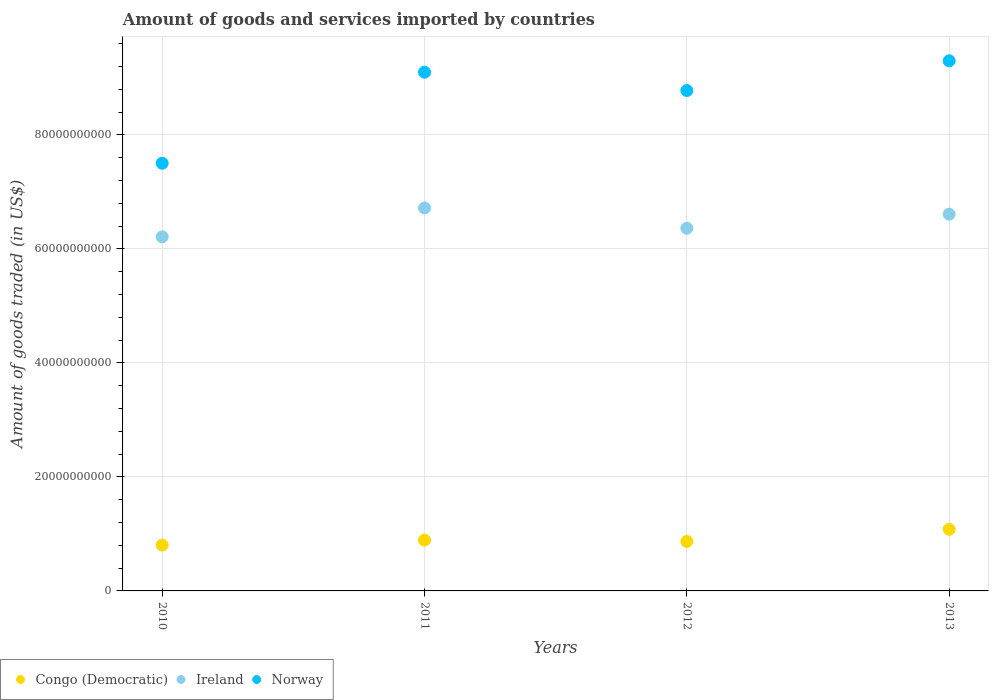How many different coloured dotlines are there?
Keep it short and to the point. 3. Is the number of dotlines equal to the number of legend labels?
Your answer should be compact. Yes. What is the total amount of goods and services imported in Ireland in 2013?
Give a very brief answer. 6.61e+1. Across all years, what is the maximum total amount of goods and services imported in Congo (Democratic)?
Provide a succinct answer. 1.08e+1. Across all years, what is the minimum total amount of goods and services imported in Congo (Democratic)?
Make the answer very short. 8.04e+09. In which year was the total amount of goods and services imported in Congo (Democratic) maximum?
Ensure brevity in your answer.  2013. In which year was the total amount of goods and services imported in Congo (Democratic) minimum?
Provide a short and direct response. 2010. What is the total total amount of goods and services imported in Ireland in the graph?
Your answer should be very brief. 2.59e+11. What is the difference between the total amount of goods and services imported in Ireland in 2011 and that in 2013?
Provide a short and direct response. 1.09e+09. What is the difference between the total amount of goods and services imported in Congo (Democratic) in 2011 and the total amount of goods and services imported in Ireland in 2012?
Your answer should be very brief. -5.47e+1. What is the average total amount of goods and services imported in Congo (Democratic) per year?
Keep it short and to the point. 9.11e+09. In the year 2012, what is the difference between the total amount of goods and services imported in Congo (Democratic) and total amount of goods and services imported in Ireland?
Keep it short and to the point. -5.50e+1. What is the ratio of the total amount of goods and services imported in Norway in 2011 to that in 2012?
Ensure brevity in your answer.  1.04. Is the total amount of goods and services imported in Norway in 2011 less than that in 2012?
Provide a short and direct response. No. Is the difference between the total amount of goods and services imported in Congo (Democratic) in 2011 and 2013 greater than the difference between the total amount of goods and services imported in Ireland in 2011 and 2013?
Make the answer very short. No. What is the difference between the highest and the second highest total amount of goods and services imported in Ireland?
Keep it short and to the point. 1.09e+09. What is the difference between the highest and the lowest total amount of goods and services imported in Ireland?
Ensure brevity in your answer.  5.07e+09. Is it the case that in every year, the sum of the total amount of goods and services imported in Ireland and total amount of goods and services imported in Norway  is greater than the total amount of goods and services imported in Congo (Democratic)?
Make the answer very short. Yes. Is the total amount of goods and services imported in Norway strictly less than the total amount of goods and services imported in Congo (Democratic) over the years?
Provide a succinct answer. No. Does the graph contain grids?
Ensure brevity in your answer.  Yes. What is the title of the graph?
Offer a terse response. Amount of goods and services imported by countries. What is the label or title of the Y-axis?
Keep it short and to the point. Amount of goods traded (in US$). What is the Amount of goods traded (in US$) of Congo (Democratic) in 2010?
Make the answer very short. 8.04e+09. What is the Amount of goods traded (in US$) in Ireland in 2010?
Your response must be concise. 6.21e+1. What is the Amount of goods traded (in US$) in Norway in 2010?
Give a very brief answer. 7.50e+1. What is the Amount of goods traded (in US$) in Congo (Democratic) in 2011?
Provide a succinct answer. 8.92e+09. What is the Amount of goods traded (in US$) of Ireland in 2011?
Offer a terse response. 6.72e+1. What is the Amount of goods traded (in US$) in Norway in 2011?
Ensure brevity in your answer.  9.10e+1. What is the Amount of goods traded (in US$) of Congo (Democratic) in 2012?
Offer a terse response. 8.68e+09. What is the Amount of goods traded (in US$) in Ireland in 2012?
Give a very brief answer. 6.36e+1. What is the Amount of goods traded (in US$) in Norway in 2012?
Keep it short and to the point. 8.78e+1. What is the Amount of goods traded (in US$) in Congo (Democratic) in 2013?
Make the answer very short. 1.08e+1. What is the Amount of goods traded (in US$) in Ireland in 2013?
Keep it short and to the point. 6.61e+1. What is the Amount of goods traded (in US$) in Norway in 2013?
Offer a very short reply. 9.30e+1. Across all years, what is the maximum Amount of goods traded (in US$) of Congo (Democratic)?
Provide a succinct answer. 1.08e+1. Across all years, what is the maximum Amount of goods traded (in US$) in Ireland?
Your answer should be compact. 6.72e+1. Across all years, what is the maximum Amount of goods traded (in US$) of Norway?
Your response must be concise. 9.30e+1. Across all years, what is the minimum Amount of goods traded (in US$) of Congo (Democratic)?
Ensure brevity in your answer.  8.04e+09. Across all years, what is the minimum Amount of goods traded (in US$) of Ireland?
Keep it short and to the point. 6.21e+1. Across all years, what is the minimum Amount of goods traded (in US$) in Norway?
Give a very brief answer. 7.50e+1. What is the total Amount of goods traded (in US$) in Congo (Democratic) in the graph?
Keep it short and to the point. 3.64e+1. What is the total Amount of goods traded (in US$) of Ireland in the graph?
Ensure brevity in your answer.  2.59e+11. What is the total Amount of goods traded (in US$) in Norway in the graph?
Offer a very short reply. 3.47e+11. What is the difference between the Amount of goods traded (in US$) in Congo (Democratic) in 2010 and that in 2011?
Your answer should be very brief. -8.73e+08. What is the difference between the Amount of goods traded (in US$) in Ireland in 2010 and that in 2011?
Provide a short and direct response. -5.07e+09. What is the difference between the Amount of goods traded (in US$) in Norway in 2010 and that in 2011?
Offer a very short reply. -1.60e+1. What is the difference between the Amount of goods traded (in US$) in Congo (Democratic) in 2010 and that in 2012?
Provide a short and direct response. -6.35e+08. What is the difference between the Amount of goods traded (in US$) of Ireland in 2010 and that in 2012?
Give a very brief answer. -1.50e+09. What is the difference between the Amount of goods traded (in US$) of Norway in 2010 and that in 2012?
Provide a succinct answer. -1.28e+1. What is the difference between the Amount of goods traded (in US$) of Congo (Democratic) in 2010 and that in 2013?
Give a very brief answer. -2.77e+09. What is the difference between the Amount of goods traded (in US$) of Ireland in 2010 and that in 2013?
Give a very brief answer. -3.98e+09. What is the difference between the Amount of goods traded (in US$) of Norway in 2010 and that in 2013?
Provide a short and direct response. -1.80e+1. What is the difference between the Amount of goods traded (in US$) in Congo (Democratic) in 2011 and that in 2012?
Provide a succinct answer. 2.38e+08. What is the difference between the Amount of goods traded (in US$) in Ireland in 2011 and that in 2012?
Ensure brevity in your answer.  3.57e+09. What is the difference between the Amount of goods traded (in US$) of Norway in 2011 and that in 2012?
Your answer should be very brief. 3.21e+09. What is the difference between the Amount of goods traded (in US$) of Congo (Democratic) in 2011 and that in 2013?
Provide a short and direct response. -1.89e+09. What is the difference between the Amount of goods traded (in US$) of Ireland in 2011 and that in 2013?
Your answer should be very brief. 1.09e+09. What is the difference between the Amount of goods traded (in US$) in Norway in 2011 and that in 2013?
Provide a short and direct response. -2.00e+09. What is the difference between the Amount of goods traded (in US$) of Congo (Democratic) in 2012 and that in 2013?
Your response must be concise. -2.13e+09. What is the difference between the Amount of goods traded (in US$) in Ireland in 2012 and that in 2013?
Give a very brief answer. -2.47e+09. What is the difference between the Amount of goods traded (in US$) in Norway in 2012 and that in 2013?
Your response must be concise. -5.22e+09. What is the difference between the Amount of goods traded (in US$) in Congo (Democratic) in 2010 and the Amount of goods traded (in US$) in Ireland in 2011?
Make the answer very short. -5.92e+1. What is the difference between the Amount of goods traded (in US$) in Congo (Democratic) in 2010 and the Amount of goods traded (in US$) in Norway in 2011?
Your response must be concise. -8.30e+1. What is the difference between the Amount of goods traded (in US$) in Ireland in 2010 and the Amount of goods traded (in US$) in Norway in 2011?
Offer a terse response. -2.89e+1. What is the difference between the Amount of goods traded (in US$) in Congo (Democratic) in 2010 and the Amount of goods traded (in US$) in Ireland in 2012?
Provide a succinct answer. -5.56e+1. What is the difference between the Amount of goods traded (in US$) of Congo (Democratic) in 2010 and the Amount of goods traded (in US$) of Norway in 2012?
Your response must be concise. -7.98e+1. What is the difference between the Amount of goods traded (in US$) in Ireland in 2010 and the Amount of goods traded (in US$) in Norway in 2012?
Provide a succinct answer. -2.57e+1. What is the difference between the Amount of goods traded (in US$) of Congo (Democratic) in 2010 and the Amount of goods traded (in US$) of Ireland in 2013?
Make the answer very short. -5.81e+1. What is the difference between the Amount of goods traded (in US$) of Congo (Democratic) in 2010 and the Amount of goods traded (in US$) of Norway in 2013?
Offer a terse response. -8.50e+1. What is the difference between the Amount of goods traded (in US$) of Ireland in 2010 and the Amount of goods traded (in US$) of Norway in 2013?
Make the answer very short. -3.09e+1. What is the difference between the Amount of goods traded (in US$) in Congo (Democratic) in 2011 and the Amount of goods traded (in US$) in Ireland in 2012?
Your answer should be very brief. -5.47e+1. What is the difference between the Amount of goods traded (in US$) of Congo (Democratic) in 2011 and the Amount of goods traded (in US$) of Norway in 2012?
Your answer should be very brief. -7.89e+1. What is the difference between the Amount of goods traded (in US$) of Ireland in 2011 and the Amount of goods traded (in US$) of Norway in 2012?
Keep it short and to the point. -2.06e+1. What is the difference between the Amount of goods traded (in US$) in Congo (Democratic) in 2011 and the Amount of goods traded (in US$) in Ireland in 2013?
Your response must be concise. -5.72e+1. What is the difference between the Amount of goods traded (in US$) of Congo (Democratic) in 2011 and the Amount of goods traded (in US$) of Norway in 2013?
Your answer should be compact. -8.41e+1. What is the difference between the Amount of goods traded (in US$) in Ireland in 2011 and the Amount of goods traded (in US$) in Norway in 2013?
Give a very brief answer. -2.58e+1. What is the difference between the Amount of goods traded (in US$) in Congo (Democratic) in 2012 and the Amount of goods traded (in US$) in Ireland in 2013?
Keep it short and to the point. -5.74e+1. What is the difference between the Amount of goods traded (in US$) of Congo (Democratic) in 2012 and the Amount of goods traded (in US$) of Norway in 2013?
Your answer should be compact. -8.43e+1. What is the difference between the Amount of goods traded (in US$) of Ireland in 2012 and the Amount of goods traded (in US$) of Norway in 2013?
Provide a short and direct response. -2.94e+1. What is the average Amount of goods traded (in US$) in Congo (Democratic) per year?
Offer a very short reply. 9.11e+09. What is the average Amount of goods traded (in US$) of Ireland per year?
Your answer should be very brief. 6.48e+1. What is the average Amount of goods traded (in US$) of Norway per year?
Give a very brief answer. 8.67e+1. In the year 2010, what is the difference between the Amount of goods traded (in US$) of Congo (Democratic) and Amount of goods traded (in US$) of Ireland?
Keep it short and to the point. -5.41e+1. In the year 2010, what is the difference between the Amount of goods traded (in US$) of Congo (Democratic) and Amount of goods traded (in US$) of Norway?
Provide a short and direct response. -6.70e+1. In the year 2010, what is the difference between the Amount of goods traded (in US$) in Ireland and Amount of goods traded (in US$) in Norway?
Give a very brief answer. -1.29e+1. In the year 2011, what is the difference between the Amount of goods traded (in US$) of Congo (Democratic) and Amount of goods traded (in US$) of Ireland?
Provide a short and direct response. -5.83e+1. In the year 2011, what is the difference between the Amount of goods traded (in US$) in Congo (Democratic) and Amount of goods traded (in US$) in Norway?
Your answer should be very brief. -8.21e+1. In the year 2011, what is the difference between the Amount of goods traded (in US$) of Ireland and Amount of goods traded (in US$) of Norway?
Your response must be concise. -2.38e+1. In the year 2012, what is the difference between the Amount of goods traded (in US$) in Congo (Democratic) and Amount of goods traded (in US$) in Ireland?
Give a very brief answer. -5.50e+1. In the year 2012, what is the difference between the Amount of goods traded (in US$) in Congo (Democratic) and Amount of goods traded (in US$) in Norway?
Give a very brief answer. -7.91e+1. In the year 2012, what is the difference between the Amount of goods traded (in US$) of Ireland and Amount of goods traded (in US$) of Norway?
Give a very brief answer. -2.42e+1. In the year 2013, what is the difference between the Amount of goods traded (in US$) of Congo (Democratic) and Amount of goods traded (in US$) of Ireland?
Offer a terse response. -5.53e+1. In the year 2013, what is the difference between the Amount of goods traded (in US$) of Congo (Democratic) and Amount of goods traded (in US$) of Norway?
Make the answer very short. -8.22e+1. In the year 2013, what is the difference between the Amount of goods traded (in US$) of Ireland and Amount of goods traded (in US$) of Norway?
Offer a very short reply. -2.69e+1. What is the ratio of the Amount of goods traded (in US$) in Congo (Democratic) in 2010 to that in 2011?
Your answer should be very brief. 0.9. What is the ratio of the Amount of goods traded (in US$) of Ireland in 2010 to that in 2011?
Provide a succinct answer. 0.92. What is the ratio of the Amount of goods traded (in US$) of Norway in 2010 to that in 2011?
Provide a short and direct response. 0.82. What is the ratio of the Amount of goods traded (in US$) in Congo (Democratic) in 2010 to that in 2012?
Your answer should be compact. 0.93. What is the ratio of the Amount of goods traded (in US$) in Ireland in 2010 to that in 2012?
Your answer should be compact. 0.98. What is the ratio of the Amount of goods traded (in US$) of Norway in 2010 to that in 2012?
Give a very brief answer. 0.85. What is the ratio of the Amount of goods traded (in US$) of Congo (Democratic) in 2010 to that in 2013?
Your response must be concise. 0.74. What is the ratio of the Amount of goods traded (in US$) of Ireland in 2010 to that in 2013?
Keep it short and to the point. 0.94. What is the ratio of the Amount of goods traded (in US$) in Norway in 2010 to that in 2013?
Provide a succinct answer. 0.81. What is the ratio of the Amount of goods traded (in US$) of Congo (Democratic) in 2011 to that in 2012?
Give a very brief answer. 1.03. What is the ratio of the Amount of goods traded (in US$) in Ireland in 2011 to that in 2012?
Your answer should be compact. 1.06. What is the ratio of the Amount of goods traded (in US$) in Norway in 2011 to that in 2012?
Ensure brevity in your answer.  1.04. What is the ratio of the Amount of goods traded (in US$) in Congo (Democratic) in 2011 to that in 2013?
Make the answer very short. 0.82. What is the ratio of the Amount of goods traded (in US$) of Ireland in 2011 to that in 2013?
Your response must be concise. 1.02. What is the ratio of the Amount of goods traded (in US$) of Norway in 2011 to that in 2013?
Provide a succinct answer. 0.98. What is the ratio of the Amount of goods traded (in US$) in Congo (Democratic) in 2012 to that in 2013?
Give a very brief answer. 0.8. What is the ratio of the Amount of goods traded (in US$) of Ireland in 2012 to that in 2013?
Offer a very short reply. 0.96. What is the ratio of the Amount of goods traded (in US$) of Norway in 2012 to that in 2013?
Give a very brief answer. 0.94. What is the difference between the highest and the second highest Amount of goods traded (in US$) of Congo (Democratic)?
Your answer should be very brief. 1.89e+09. What is the difference between the highest and the second highest Amount of goods traded (in US$) of Ireland?
Your response must be concise. 1.09e+09. What is the difference between the highest and the second highest Amount of goods traded (in US$) of Norway?
Keep it short and to the point. 2.00e+09. What is the difference between the highest and the lowest Amount of goods traded (in US$) in Congo (Democratic)?
Give a very brief answer. 2.77e+09. What is the difference between the highest and the lowest Amount of goods traded (in US$) in Ireland?
Offer a terse response. 5.07e+09. What is the difference between the highest and the lowest Amount of goods traded (in US$) of Norway?
Offer a very short reply. 1.80e+1. 